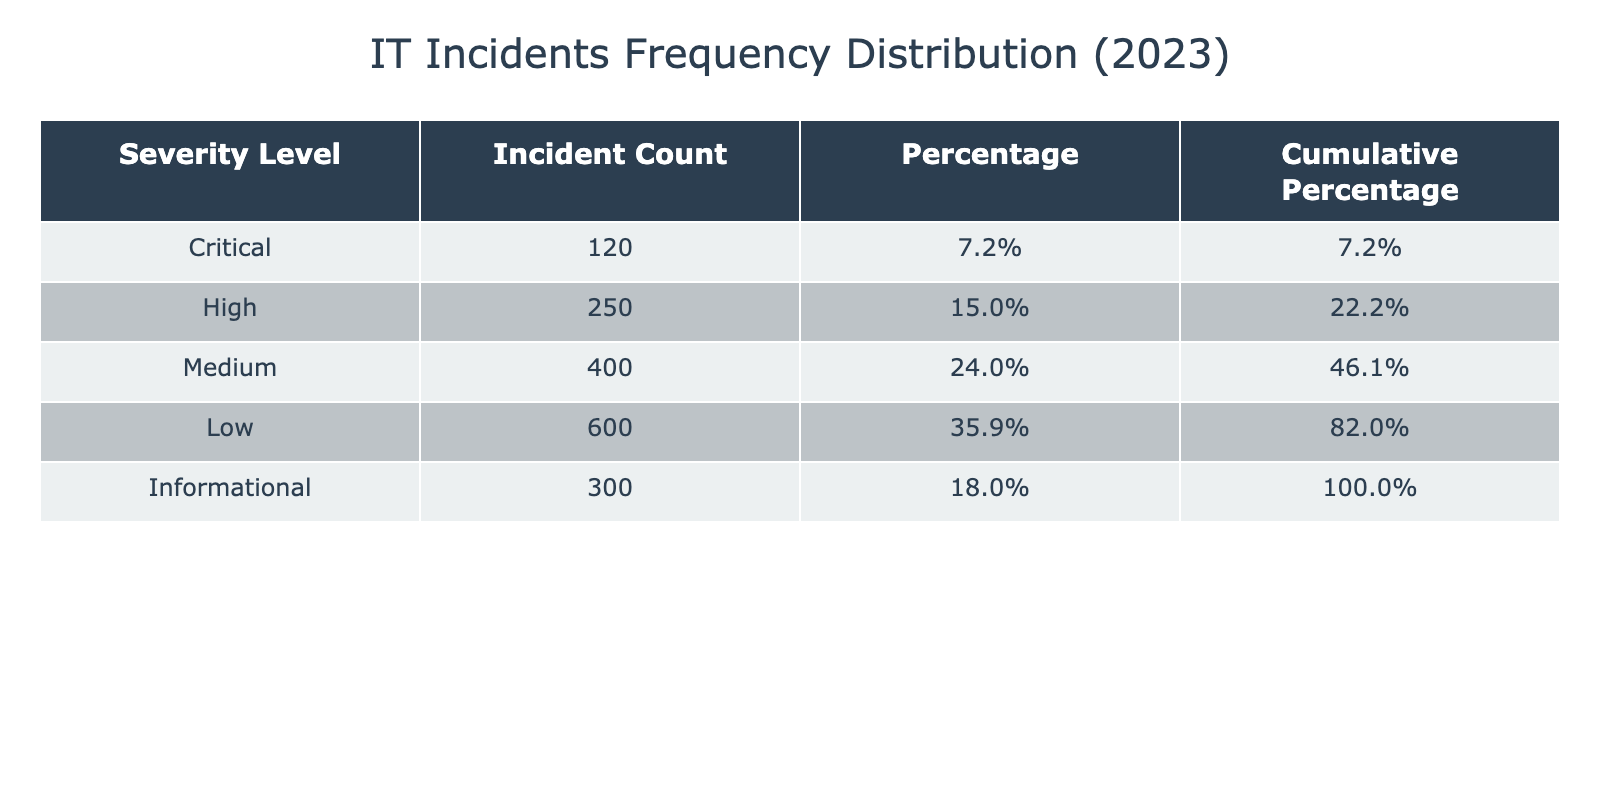What is the incident count for High severity incidents? The table shows that the incident count for High severity incidents is listed under the "Incident Count" column for the "High" row. Referring to the table, it is found to be 250.
Answer: 250 What percentage of total incidents are classified as Critical? First, determine the total number of incidents by summing all the incident counts. The total is 120 + 250 + 400 + 600 + 300 = 1670. Now, the percentage for Critical severity is calculated as (120 / 1670) * 100, which equals approximately 7.2%.
Answer: 7.2% Is the number of Medium severity incidents greater than the combined count of Low and Informational incidents? First, find the counts: Medium is 400, Low is 600, and Informational is 300. Adding Low and Informational gives 600 + 300 = 900. Since 400 is less than 900, the answer is No.
Answer: No How many incidents fall under the Low severity category? The incident count for Low severity level can be directly retrieved from the table, where it states the count for Low is listed as 600 incidents.
Answer: 600 What is the cumulative percentage of incidents for Medium and Low severity levels combined? The cumulative percentage for Medium is found to be 40.5% and for Low it is 67.5%. Therefore, to find the total cumulative percentage for Medium and Low, we can take 67.5% for Low since it includes all previous percentages. This means that the cumulative percentage for both is 67.5%.
Answer: 67.5% 